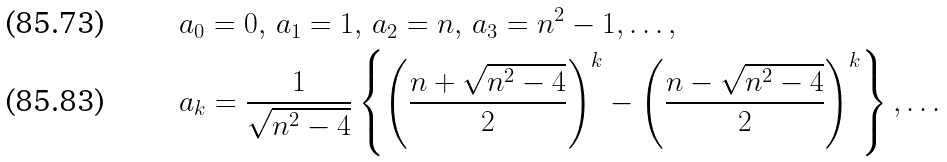Convert formula to latex. <formula><loc_0><loc_0><loc_500><loc_500>& a _ { 0 } = 0 , \, a _ { 1 } = 1 , \, a _ { 2 } = n , \, a _ { 3 } = n ^ { 2 } - 1 , \dots , \\ & a _ { k } = \frac { 1 } { \sqrt { n ^ { 2 } - 4 } } \left \{ \left ( \frac { n + \sqrt { n ^ { 2 } - 4 } } { 2 } \right ) ^ { k } - \left ( \frac { n - \sqrt { n ^ { 2 } - 4 } } { 2 } \right ) ^ { k } \right \} , \dots</formula> 